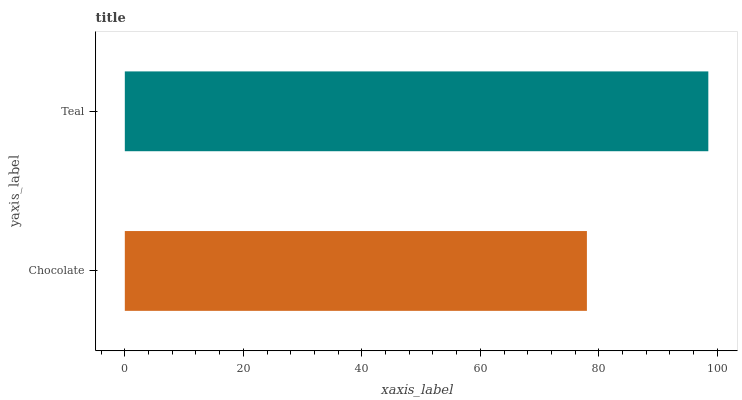Is Chocolate the minimum?
Answer yes or no. Yes. Is Teal the maximum?
Answer yes or no. Yes. Is Teal the minimum?
Answer yes or no. No. Is Teal greater than Chocolate?
Answer yes or no. Yes. Is Chocolate less than Teal?
Answer yes or no. Yes. Is Chocolate greater than Teal?
Answer yes or no. No. Is Teal less than Chocolate?
Answer yes or no. No. Is Teal the high median?
Answer yes or no. Yes. Is Chocolate the low median?
Answer yes or no. Yes. Is Chocolate the high median?
Answer yes or no. No. Is Teal the low median?
Answer yes or no. No. 